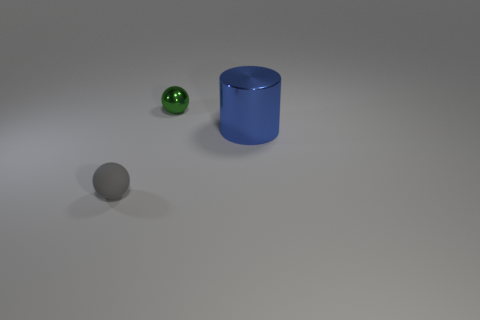Add 3 blue rubber cylinders. How many objects exist? 6 Subtract all cylinders. How many objects are left? 2 Subtract all large cylinders. Subtract all blue things. How many objects are left? 1 Add 3 big metal cylinders. How many big metal cylinders are left? 4 Add 3 small yellow metal spheres. How many small yellow metal spheres exist? 3 Subtract 0 purple balls. How many objects are left? 3 